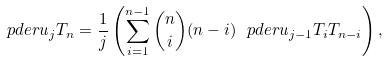Convert formula to latex. <formula><loc_0><loc_0><loc_500><loc_500>\ p d e r { u _ { j } } { T _ { n } } = \frac { 1 } { j } \left ( \sum _ { i = 1 } ^ { n - 1 } { \binom { n } { i } } ( n - i ) \ p d e r { u _ { j - 1 } } { T _ { i } } T _ { n - i } \right ) ,</formula> 